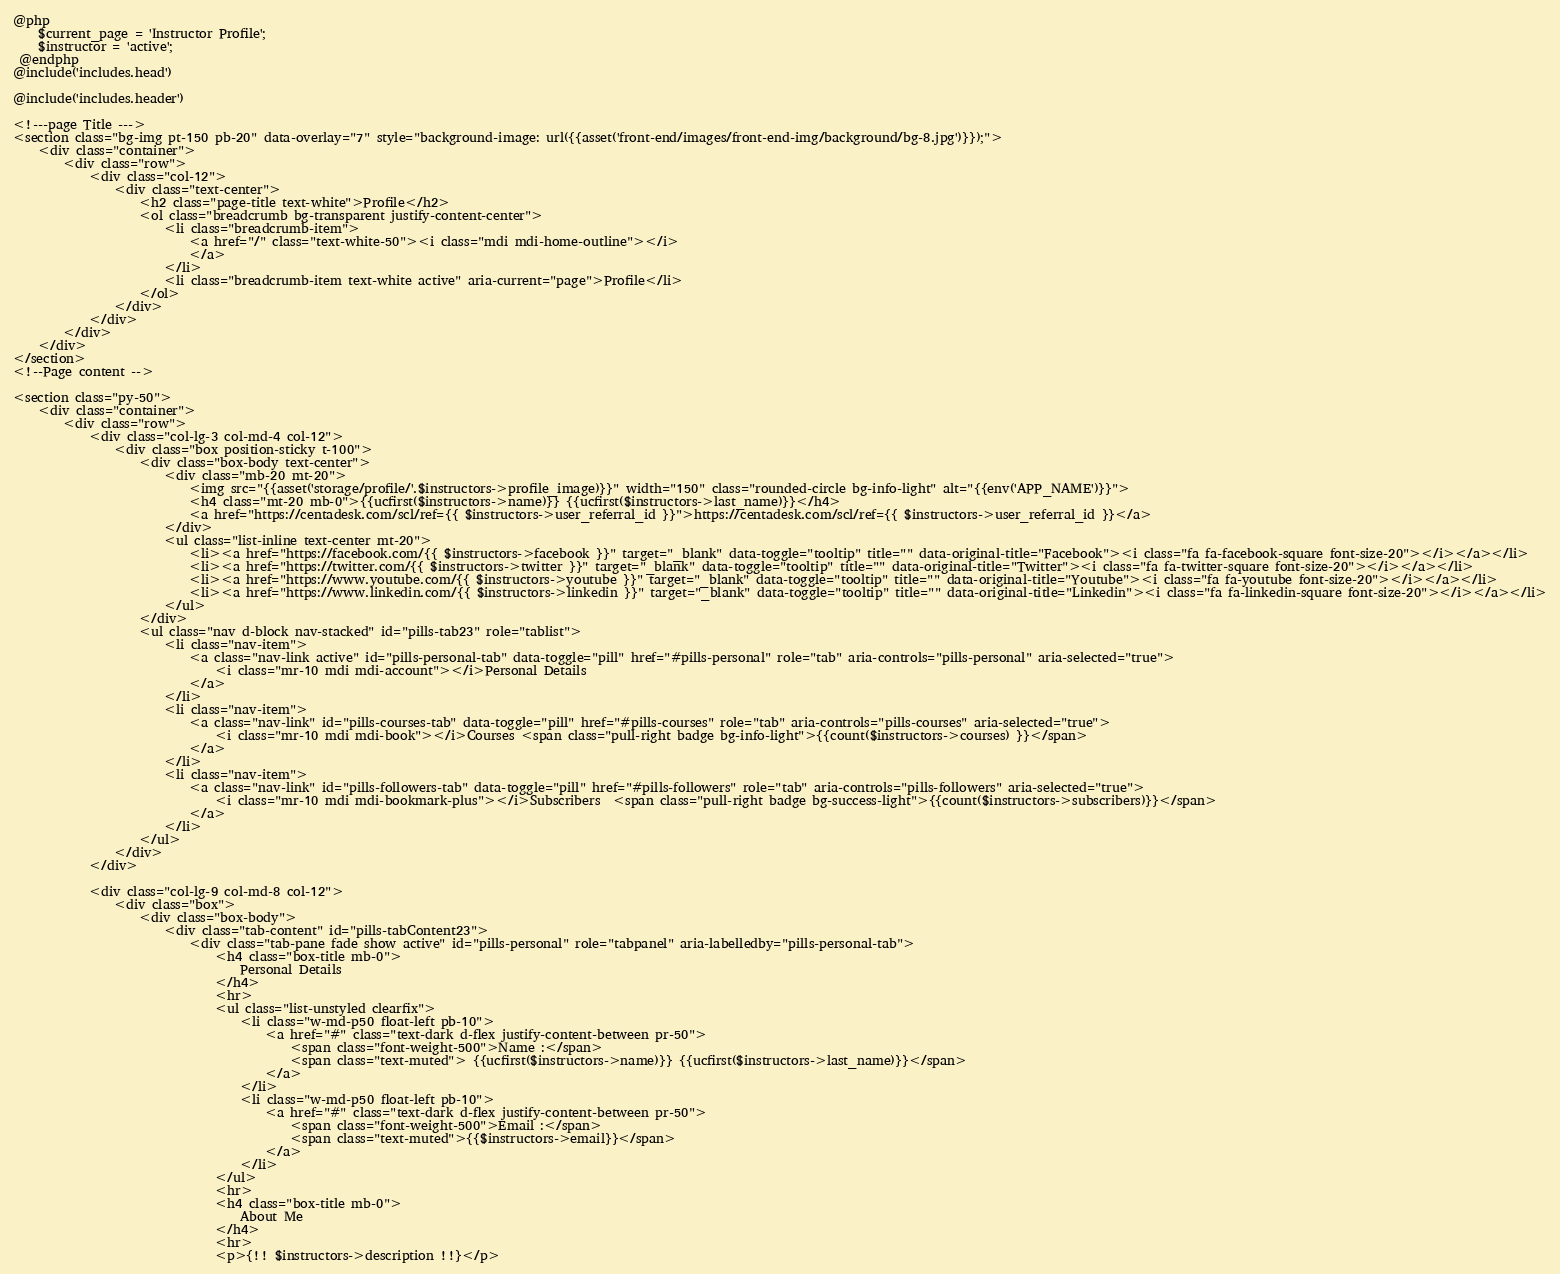<code> <loc_0><loc_0><loc_500><loc_500><_PHP_>@php
    $current_page = 'Instructor Profile';
    $instructor = 'active';
 @endphp
@include('includes.head')

@include('includes.header')

<!---page Title --->
<section class="bg-img pt-150 pb-20" data-overlay="7" style="background-image: url({{asset('front-end/images/front-end-img/background/bg-8.jpg')}});">
    <div class="container">
        <div class="row">
            <div class="col-12">
                <div class="text-center">
                    <h2 class="page-title text-white">Profile</h2>
                    <ol class="breadcrumb bg-transparent justify-content-center">
                        <li class="breadcrumb-item">
                            <a href="/" class="text-white-50"><i class="mdi mdi-home-outline"></i>
                            </a>
                        </li>
                        <li class="breadcrumb-item text-white active" aria-current="page">Profile</li>
                    </ol>
                </div>
            </div>
        </div>
    </div>
</section>
<!--Page content -->

<section class="py-50">
    <div class="container">
        <div class="row">
            <div class="col-lg-3 col-md-4 col-12">
                <div class="box position-sticky t-100">
                    <div class="box-body text-center">
                        <div class="mb-20 mt-20">
                            <img src="{{asset('storage/profile/'.$instructors->profile_image)}}" width="150" class="rounded-circle bg-info-light" alt="{{env('APP_NAME')}}">
                            <h4 class="mt-20 mb-0">{{ucfirst($instructors->name)}} {{ucfirst($instructors->last_name)}}</h4>
                            <a href="https://centadesk.com/scl/ref={{ $instructors->user_referral_id }}">https://centadesk.com/scl/ref={{ $instructors->user_referral_id }}</a>
                        </div>
                        <ul class="list-inline text-center mt-20">
                            <li><a href="https://facebook.com/{{ $instructors->facebook }}" target="_blank" data-toggle="tooltip" title="" data-original-title="Facebook"><i class="fa fa-facebook-square font-size-20"></i></a></li>
                            <li><a href="https://twitter.com/{{ $instructors->twitter }}" target="_blank" data-toggle="tooltip" title="" data-original-title="Twitter"><i class="fa fa-twitter-square font-size-20"></i></a></li>
                            <li><a href="https://www.youtube.com/{{ $instructors->youtube }}" target="_blank" data-toggle="tooltip" title="" data-original-title="Youtube"><i class="fa fa-youtube font-size-20"></i></a></li>
                            <li><a href="https://www.linkedin.com/{{ $instructors->linkedin }}" target="_blank" data-toggle="tooltip" title="" data-original-title="Linkedin"><i class="fa fa-linkedin-square font-size-20"></i></a></li>
                        </ul>
                    </div>
                    <ul class="nav d-block nav-stacked" id="pills-tab23" role="tablist">
                        <li class="nav-item">
                            <a class="nav-link active" id="pills-personal-tab" data-toggle="pill" href="#pills-personal" role="tab" aria-controls="pills-personal" aria-selected="true">
                                <i class="mr-10 mdi mdi-account"></i>Personal Details
                            </a>
                        </li>
                        <li class="nav-item">
                            <a class="nav-link" id="pills-courses-tab" data-toggle="pill" href="#pills-courses" role="tab" aria-controls="pills-courses" aria-selected="true">
                                <i class="mr-10 mdi mdi-book"></i>Courses <span class="pull-right badge bg-info-light">{{count($instructors->courses) }}</span>
                            </a>
                        </li>
                        <li class="nav-item">
                            <a class="nav-link" id="pills-followers-tab" data-toggle="pill" href="#pills-followers" role="tab" aria-controls="pills-followers" aria-selected="true">
                                <i class="mr-10 mdi mdi-bookmark-plus"></i>Subscribers  <span class="pull-right badge bg-success-light">{{count($instructors->subscribers)}}</span>
                            </a>
                        </li>
                    </ul>
                </div>
            </div>

            <div class="col-lg-9 col-md-8 col-12">
                <div class="box">
                    <div class="box-body">
                        <div class="tab-content" id="pills-tabContent23">
                            <div class="tab-pane fade show active" id="pills-personal" role="tabpanel" aria-labelledby="pills-personal-tab">
                                <h4 class="box-title mb-0">
                                    Personal Details
                                </h4>
                                <hr>
                                <ul class="list-unstyled clearfix">
                                    <li class="w-md-p50 float-left pb-10">
                                        <a href="#" class="text-dark d-flex justify-content-between pr-50">
                                            <span class="font-weight-500">Name :</span>
                                            <span class="text-muted"> {{ucfirst($instructors->name)}} {{ucfirst($instructors->last_name)}}</span>
                                        </a>
                                    </li>
                                    <li class="w-md-p50 float-left pb-10">
                                        <a href="#" class="text-dark d-flex justify-content-between pr-50">
                                            <span class="font-weight-500">Email :</span>
                                            <span class="text-muted">{{$instructors->email}}</span>
                                        </a>
                                    </li>
                                </ul>
                                <hr>
                                <h4 class="box-title mb-0">
                                    About Me
                                </h4>
                                <hr>
                                <p>{!! $instructors->description !!}</p></code> 